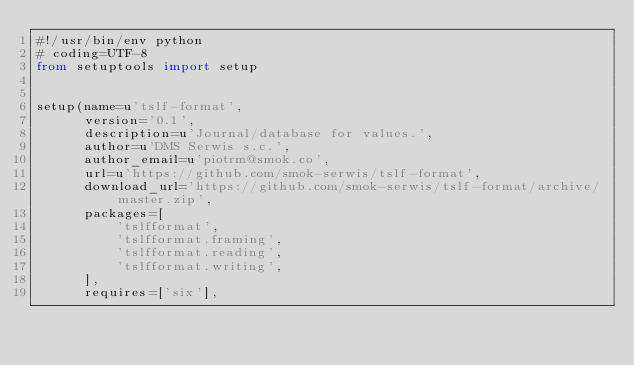Convert code to text. <code><loc_0><loc_0><loc_500><loc_500><_Python_>#!/usr/bin/env python
# coding=UTF-8
from setuptools import setup


setup(name=u'tslf-format',
      version='0.1',
      description=u'Journal/database for values.',
      author=u'DMS Serwis s.c.',
      author_email=u'piotrm@smok.co',
      url=u'https://github.com/smok-serwis/tslf-format',
      download_url='https://github.com/smok-serwis/tslf-format/archive/master.zip',
      packages=[
          'tslfformat',
          'tslfformat.framing',
          'tslfformat.reading',
          'tslfformat.writing',
      ],
      requires=['six'],</code> 